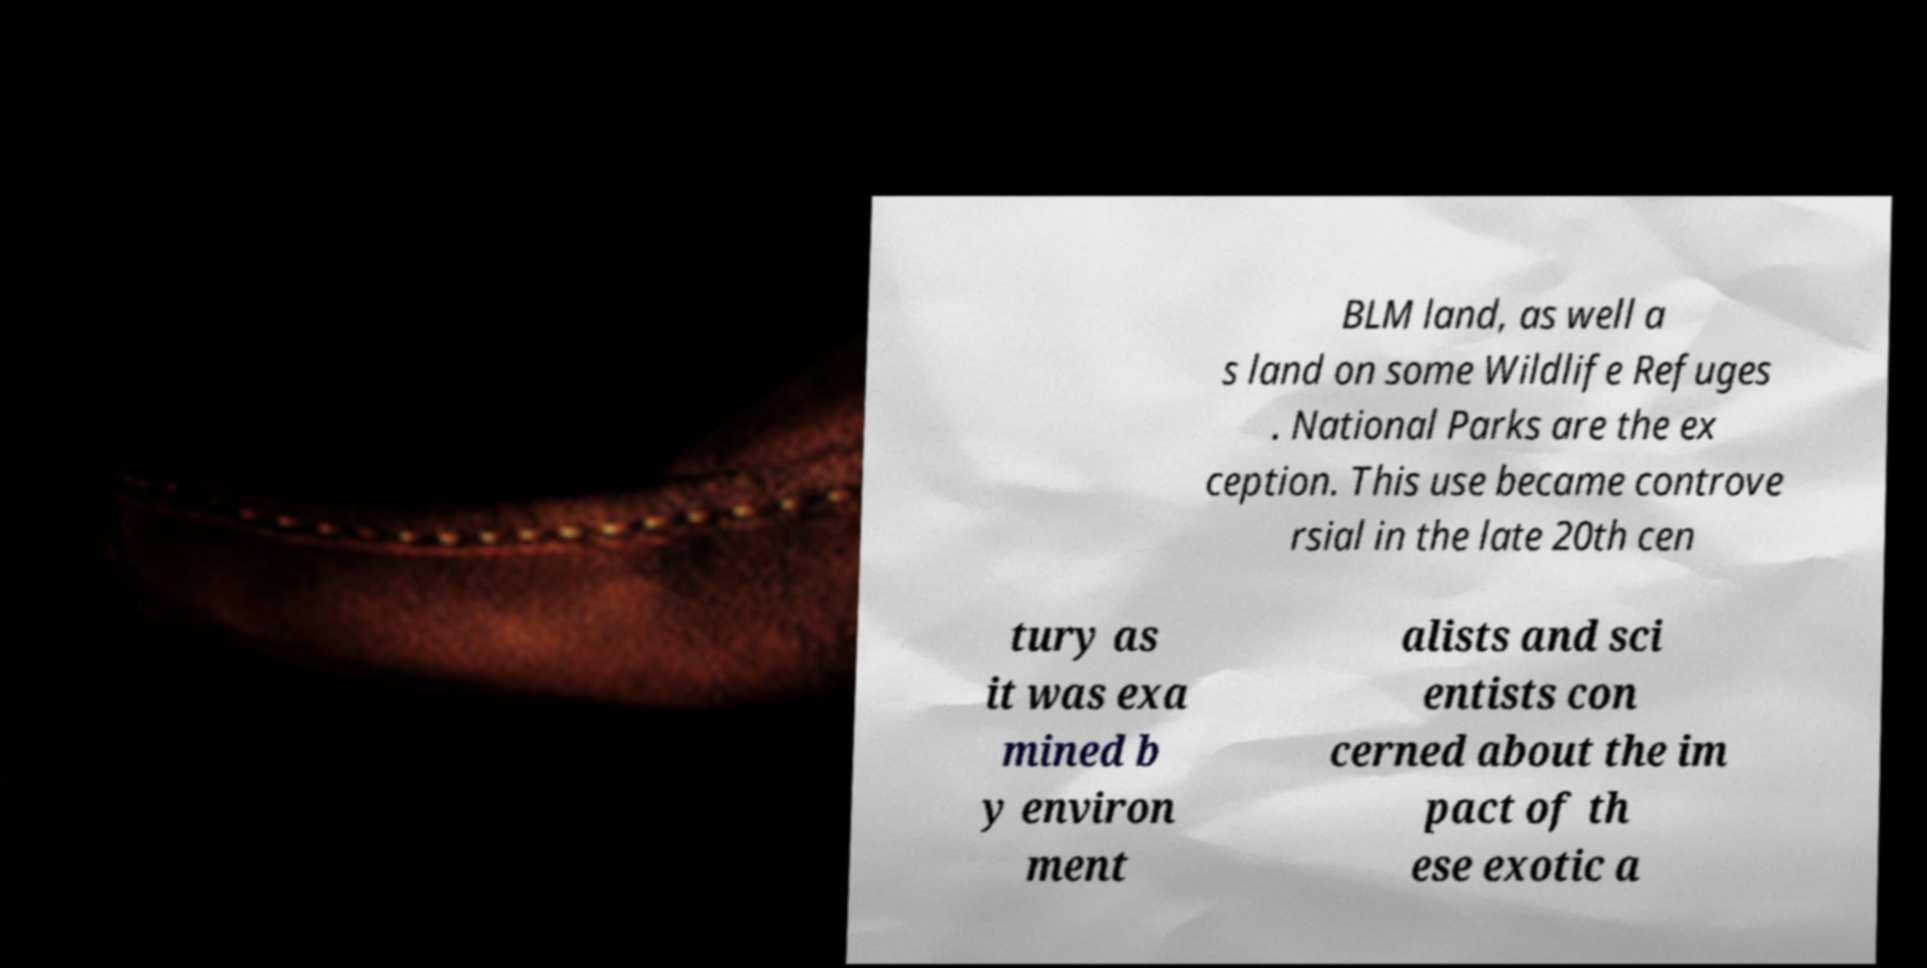What messages or text are displayed in this image? I need them in a readable, typed format. BLM land, as well a s land on some Wildlife Refuges . National Parks are the ex ception. This use became controve rsial in the late 20th cen tury as it was exa mined b y environ ment alists and sci entists con cerned about the im pact of th ese exotic a 